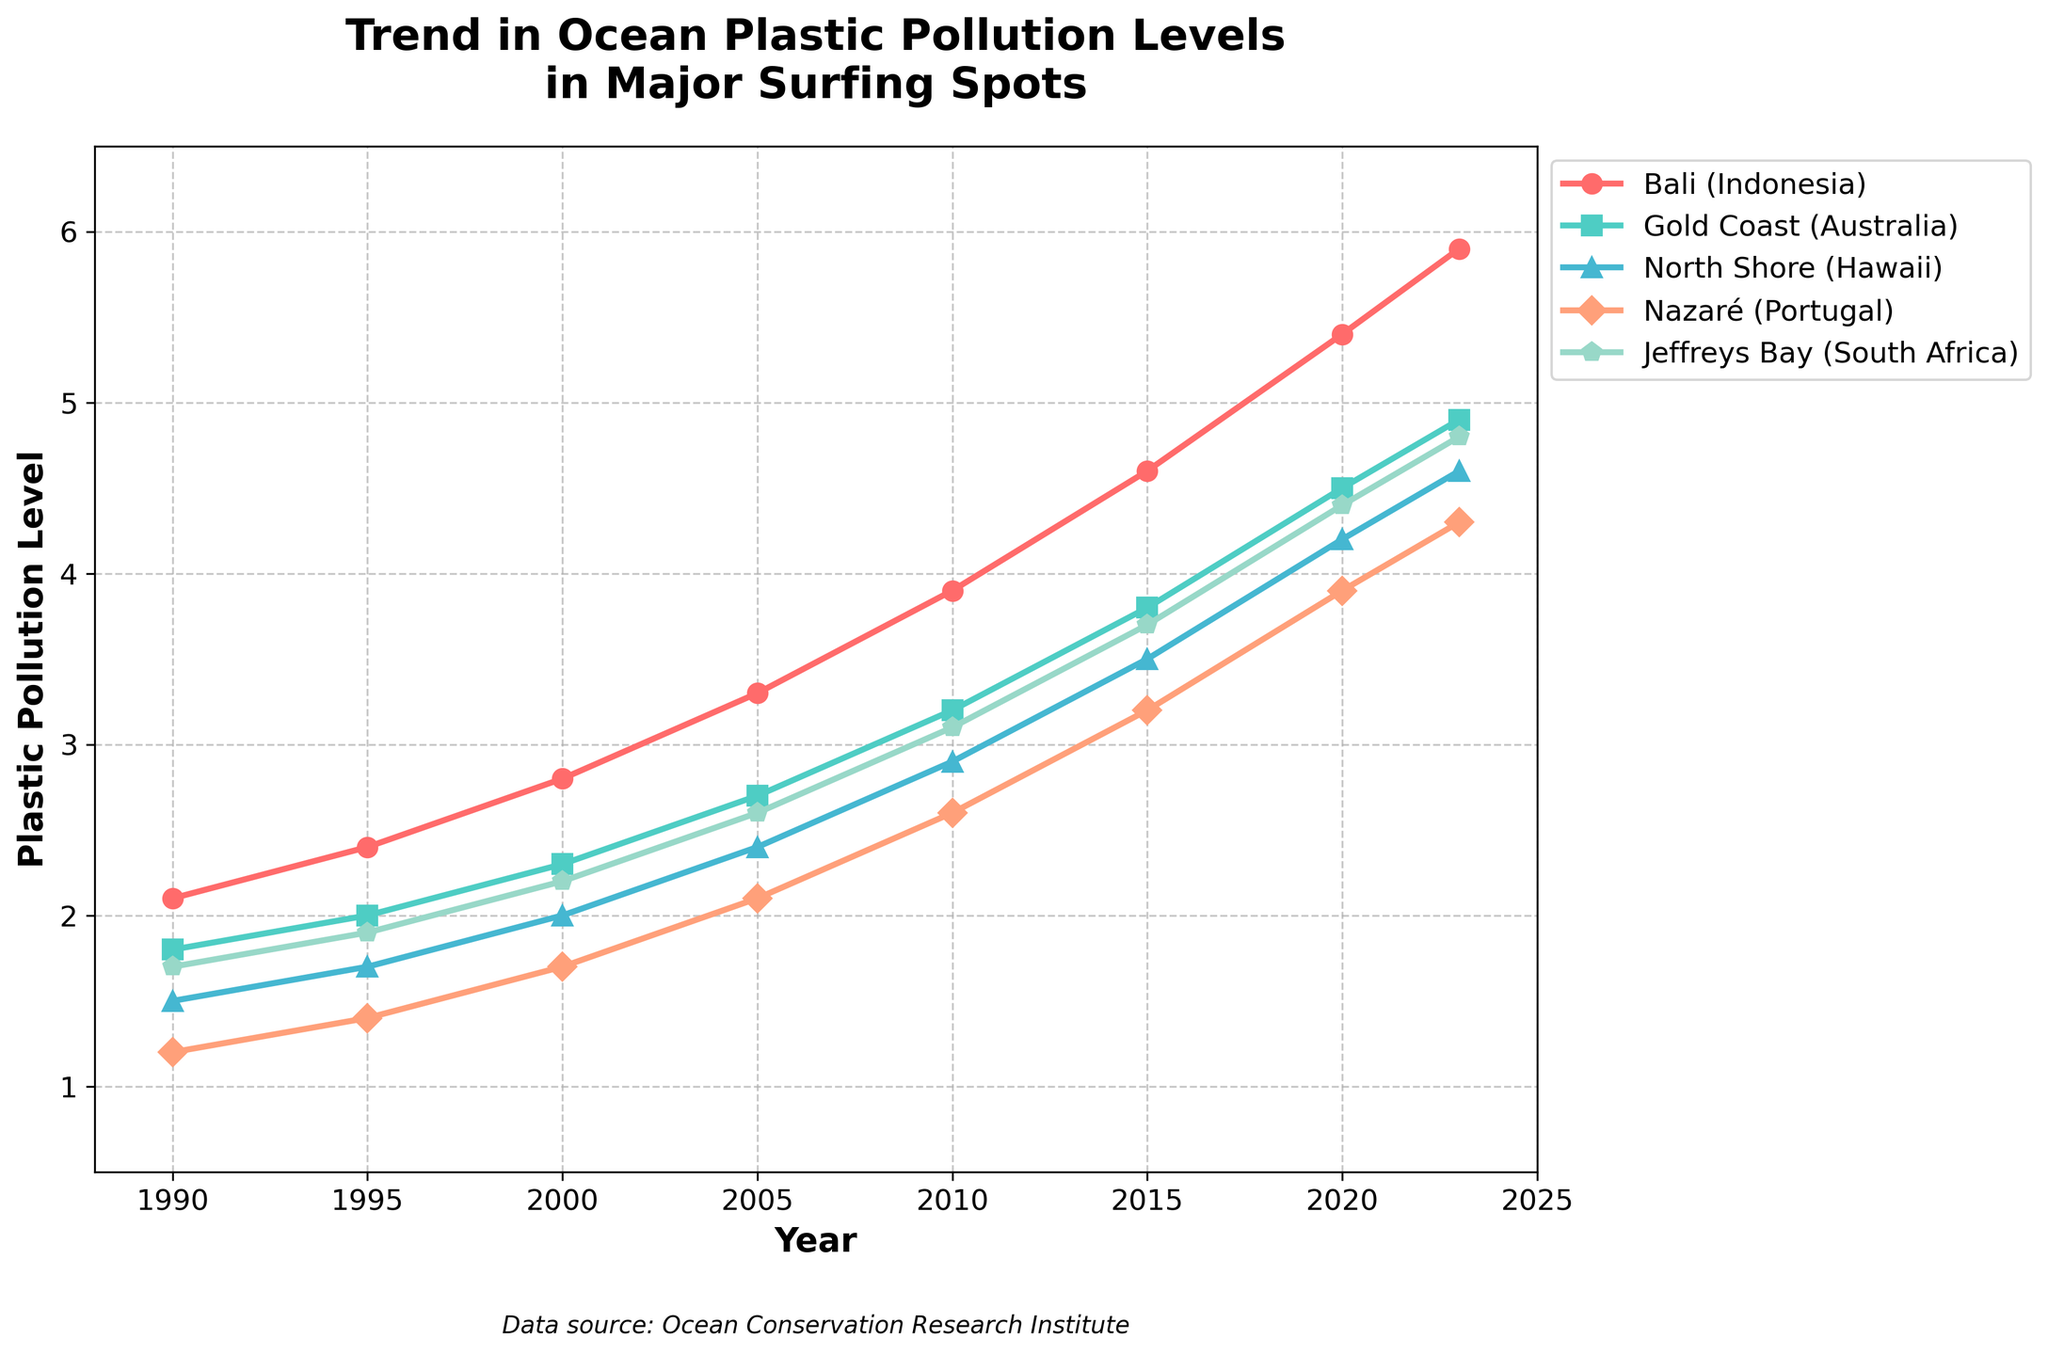Which surfing spot had the highest plastic pollution level in 2023? The highest point on the vertical axis corresponding to the year 2023 will indicate the spot with the highest pollution level. Bali (Indonesia) has the highest value.
Answer: Bali (Indonesia) How did the plastic pollution level in Jeffreys Bay (South Africa) change from 1995 to 2023? Find the value for Jeffreys Bay in 1995 and in 2023, then calculate the difference. The values are 1.9 and 4.8 respectively. The change is 4.8 - 1.9.
Answer: 2.9 In which year did plastic pollution levels at Gold Coast (Australia) first exceed 4.0? Look for the first year in which the Gold Coast (Australia) plot line crosses the 4.0 value mark on the vertical axis. This occurs in 2020 with a value of 4.5.
Answer: 2020 Between 1990 and 2023, which surfing spot had the smallest increase in plastic pollution levels? Calculate the increase for each spot by subtracting the 1990 value from the 2023 value for each:
Bali (5.9-2.1), Gold Coast (4.9-1.8), North Shore (4.6-1.5), Nazaré (4.3-1.2), Jeffreys Bay (4.8-1.7).
Smallest increase: Nazaré (3.1).
Answer: Nazaré (Portugal) What was the average plastic pollution level for North Shore (Hawaii) in 2000, 2010, and 2020 combined? Find the values for North Shore (Hawaii) in 2000, 2010, and 2020, sum them and divide by the number of years: (2.0 + 2.9 + 4.2) / 3.
Answer: 3.03 What is the difference in plastic pollution levels between Bali (Indonesia) and North Shore (Hawaii) in 2023? Locate the values for both surfing spots in 2023 and subtract the value for North Shore (Hawaii) from Bali (Indonesia): 5.9 - 4.6.
Answer: 1.3 Which three surfing spots had the highest pollution levels in 2015? Compare the values for all surfing spots in 2015 and rank them: Bali (4.6), Gold Coast (3.8), North Shore (3.5), Nazaré (3.2), Jeffreys Bay (3.7). The top three are Bali, Gold Coast, and North Shore.
Answer: Bali, Gold Coast, North Shore What is the trend in plastic pollution levels for Nazaré (Portugal) from 1990 to 2023? Observe and describe the line for Nazaré (Portugal) from 1990 to 2023, noting the consistent upward trend in values increasing from 1.2 to 4.3.
Answer: Upward trend Is the pollution level in Jeffreys Bay (South Africa) in 2010 more than in Gold Coast (Australia) in 2000? Compare the values for Jeffreys Bay (2010) and Gold Coast (2000). They are 3.1 and 2.3 respectively.
Answer: Yes By how much did the plastic pollution level increase for Bali (Indonesia) from 2005 to 2020? Determine the values for Bali in 2005 and 2020, then find the difference: 5.4 - 3.3.
Answer: 2.1 